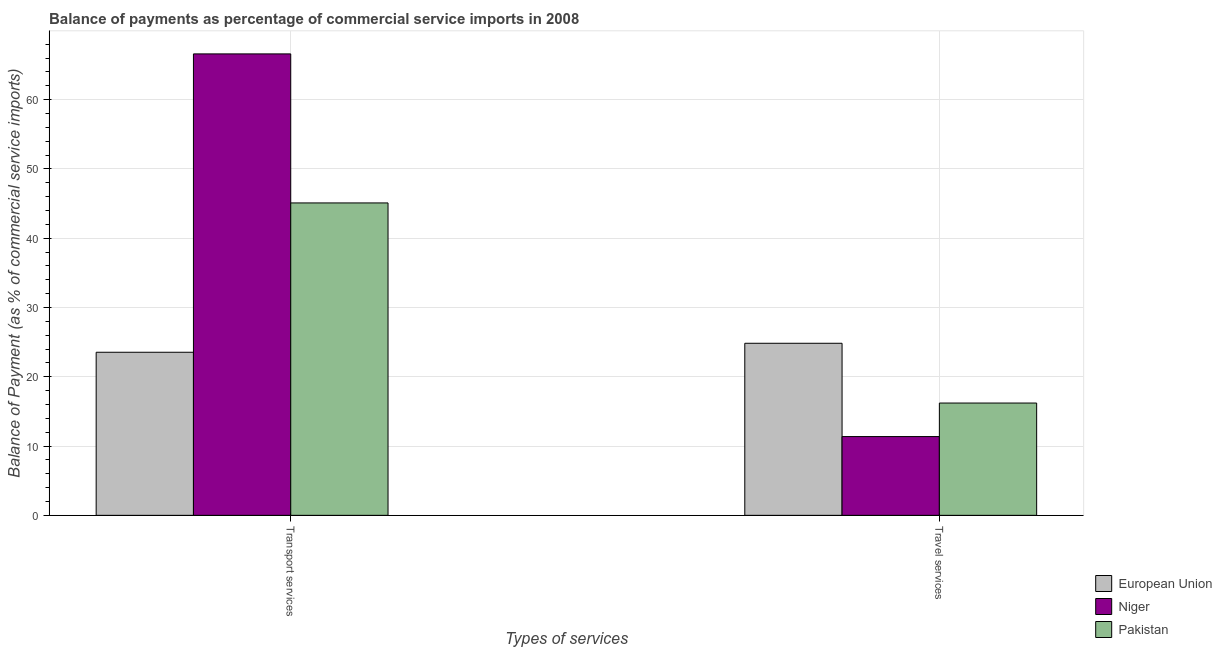How many different coloured bars are there?
Ensure brevity in your answer.  3. How many bars are there on the 2nd tick from the right?
Offer a very short reply. 3. What is the label of the 2nd group of bars from the left?
Your answer should be compact. Travel services. What is the balance of payments of transport services in European Union?
Keep it short and to the point. 23.54. Across all countries, what is the maximum balance of payments of travel services?
Provide a short and direct response. 24.84. Across all countries, what is the minimum balance of payments of travel services?
Offer a terse response. 11.37. In which country was the balance of payments of travel services maximum?
Offer a very short reply. European Union. In which country was the balance of payments of transport services minimum?
Provide a short and direct response. European Union. What is the total balance of payments of travel services in the graph?
Your answer should be compact. 52.42. What is the difference between the balance of payments of travel services in Pakistan and that in Niger?
Make the answer very short. 4.84. What is the difference between the balance of payments of travel services in Niger and the balance of payments of transport services in European Union?
Make the answer very short. -12.17. What is the average balance of payments of transport services per country?
Your answer should be compact. 45.08. What is the difference between the balance of payments of transport services and balance of payments of travel services in Pakistan?
Keep it short and to the point. 28.89. In how many countries, is the balance of payments of transport services greater than 6 %?
Give a very brief answer. 3. What is the ratio of the balance of payments of transport services in Niger to that in European Union?
Offer a very short reply. 2.83. What does the 1st bar from the right in Transport services represents?
Your answer should be compact. Pakistan. How many bars are there?
Your answer should be compact. 6. How many countries are there in the graph?
Keep it short and to the point. 3. Where does the legend appear in the graph?
Your answer should be very brief. Bottom right. What is the title of the graph?
Provide a short and direct response. Balance of payments as percentage of commercial service imports in 2008. What is the label or title of the X-axis?
Your answer should be very brief. Types of services. What is the label or title of the Y-axis?
Your answer should be compact. Balance of Payment (as % of commercial service imports). What is the Balance of Payment (as % of commercial service imports) of European Union in Transport services?
Keep it short and to the point. 23.54. What is the Balance of Payment (as % of commercial service imports) in Niger in Transport services?
Offer a very short reply. 66.61. What is the Balance of Payment (as % of commercial service imports) in Pakistan in Transport services?
Offer a very short reply. 45.1. What is the Balance of Payment (as % of commercial service imports) of European Union in Travel services?
Offer a very short reply. 24.84. What is the Balance of Payment (as % of commercial service imports) of Niger in Travel services?
Your response must be concise. 11.37. What is the Balance of Payment (as % of commercial service imports) in Pakistan in Travel services?
Offer a very short reply. 16.21. Across all Types of services, what is the maximum Balance of Payment (as % of commercial service imports) in European Union?
Give a very brief answer. 24.84. Across all Types of services, what is the maximum Balance of Payment (as % of commercial service imports) of Niger?
Provide a succinct answer. 66.61. Across all Types of services, what is the maximum Balance of Payment (as % of commercial service imports) in Pakistan?
Your answer should be very brief. 45.1. Across all Types of services, what is the minimum Balance of Payment (as % of commercial service imports) of European Union?
Provide a succinct answer. 23.54. Across all Types of services, what is the minimum Balance of Payment (as % of commercial service imports) in Niger?
Provide a succinct answer. 11.37. Across all Types of services, what is the minimum Balance of Payment (as % of commercial service imports) of Pakistan?
Keep it short and to the point. 16.21. What is the total Balance of Payment (as % of commercial service imports) in European Union in the graph?
Offer a terse response. 48.38. What is the total Balance of Payment (as % of commercial service imports) of Niger in the graph?
Ensure brevity in your answer.  77.98. What is the total Balance of Payment (as % of commercial service imports) in Pakistan in the graph?
Give a very brief answer. 61.31. What is the difference between the Balance of Payment (as % of commercial service imports) of European Union in Transport services and that in Travel services?
Your response must be concise. -1.3. What is the difference between the Balance of Payment (as % of commercial service imports) in Niger in Transport services and that in Travel services?
Keep it short and to the point. 55.24. What is the difference between the Balance of Payment (as % of commercial service imports) in Pakistan in Transport services and that in Travel services?
Your answer should be compact. 28.89. What is the difference between the Balance of Payment (as % of commercial service imports) of European Union in Transport services and the Balance of Payment (as % of commercial service imports) of Niger in Travel services?
Keep it short and to the point. 12.17. What is the difference between the Balance of Payment (as % of commercial service imports) in European Union in Transport services and the Balance of Payment (as % of commercial service imports) in Pakistan in Travel services?
Your answer should be compact. 7.33. What is the difference between the Balance of Payment (as % of commercial service imports) in Niger in Transport services and the Balance of Payment (as % of commercial service imports) in Pakistan in Travel services?
Provide a succinct answer. 50.4. What is the average Balance of Payment (as % of commercial service imports) in European Union per Types of services?
Ensure brevity in your answer.  24.19. What is the average Balance of Payment (as % of commercial service imports) of Niger per Types of services?
Give a very brief answer. 38.99. What is the average Balance of Payment (as % of commercial service imports) of Pakistan per Types of services?
Ensure brevity in your answer.  30.65. What is the difference between the Balance of Payment (as % of commercial service imports) in European Union and Balance of Payment (as % of commercial service imports) in Niger in Transport services?
Offer a terse response. -43.07. What is the difference between the Balance of Payment (as % of commercial service imports) in European Union and Balance of Payment (as % of commercial service imports) in Pakistan in Transport services?
Offer a very short reply. -21.56. What is the difference between the Balance of Payment (as % of commercial service imports) in Niger and Balance of Payment (as % of commercial service imports) in Pakistan in Transport services?
Your answer should be very brief. 21.51. What is the difference between the Balance of Payment (as % of commercial service imports) of European Union and Balance of Payment (as % of commercial service imports) of Niger in Travel services?
Your response must be concise. 13.47. What is the difference between the Balance of Payment (as % of commercial service imports) of European Union and Balance of Payment (as % of commercial service imports) of Pakistan in Travel services?
Provide a short and direct response. 8.63. What is the difference between the Balance of Payment (as % of commercial service imports) of Niger and Balance of Payment (as % of commercial service imports) of Pakistan in Travel services?
Make the answer very short. -4.84. What is the ratio of the Balance of Payment (as % of commercial service imports) in European Union in Transport services to that in Travel services?
Your answer should be compact. 0.95. What is the ratio of the Balance of Payment (as % of commercial service imports) of Niger in Transport services to that in Travel services?
Your answer should be very brief. 5.86. What is the ratio of the Balance of Payment (as % of commercial service imports) in Pakistan in Transport services to that in Travel services?
Your response must be concise. 2.78. What is the difference between the highest and the second highest Balance of Payment (as % of commercial service imports) of European Union?
Give a very brief answer. 1.3. What is the difference between the highest and the second highest Balance of Payment (as % of commercial service imports) in Niger?
Your answer should be very brief. 55.24. What is the difference between the highest and the second highest Balance of Payment (as % of commercial service imports) in Pakistan?
Your answer should be very brief. 28.89. What is the difference between the highest and the lowest Balance of Payment (as % of commercial service imports) in European Union?
Ensure brevity in your answer.  1.3. What is the difference between the highest and the lowest Balance of Payment (as % of commercial service imports) of Niger?
Give a very brief answer. 55.24. What is the difference between the highest and the lowest Balance of Payment (as % of commercial service imports) in Pakistan?
Your answer should be very brief. 28.89. 